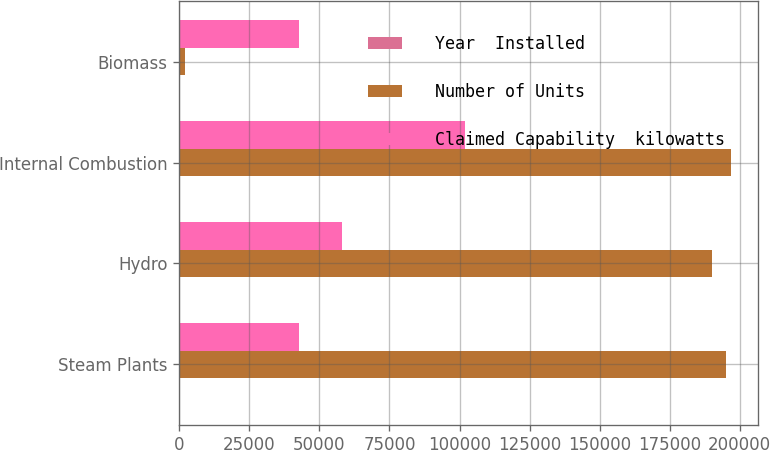Convert chart to OTSL. <chart><loc_0><loc_0><loc_500><loc_500><stacked_bar_chart><ecel><fcel>Steam Plants<fcel>Hydro<fcel>Internal Combustion<fcel>Biomass<nl><fcel>Year  Installed<fcel>5<fcel>20<fcel>5<fcel>1<nl><fcel>Number of Units<fcel>195274<fcel>190183<fcel>196870<fcel>2006<nl><fcel>Claimed Capability  kilowatts<fcel>42594<fcel>58115<fcel>101869<fcel>42594<nl></chart> 